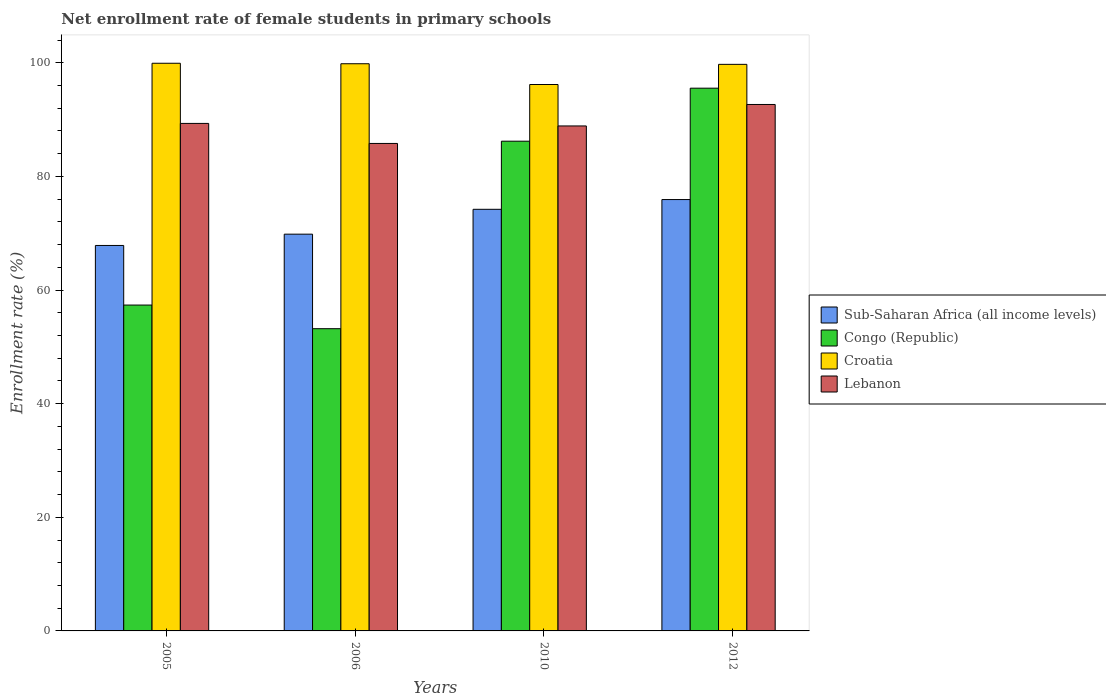How many groups of bars are there?
Your response must be concise. 4. Are the number of bars per tick equal to the number of legend labels?
Keep it short and to the point. Yes. How many bars are there on the 3rd tick from the right?
Offer a very short reply. 4. What is the net enrollment rate of female students in primary schools in Croatia in 2006?
Give a very brief answer. 99.83. Across all years, what is the maximum net enrollment rate of female students in primary schools in Lebanon?
Your answer should be compact. 92.67. Across all years, what is the minimum net enrollment rate of female students in primary schools in Lebanon?
Ensure brevity in your answer.  85.81. What is the total net enrollment rate of female students in primary schools in Croatia in the graph?
Your response must be concise. 395.66. What is the difference between the net enrollment rate of female students in primary schools in Croatia in 2010 and that in 2012?
Provide a succinct answer. -3.55. What is the difference between the net enrollment rate of female students in primary schools in Sub-Saharan Africa (all income levels) in 2010 and the net enrollment rate of female students in primary schools in Congo (Republic) in 2012?
Offer a terse response. -21.32. What is the average net enrollment rate of female students in primary schools in Congo (Republic) per year?
Your answer should be very brief. 73.07. In the year 2006, what is the difference between the net enrollment rate of female students in primary schools in Croatia and net enrollment rate of female students in primary schools in Congo (Republic)?
Your answer should be compact. 46.64. In how many years, is the net enrollment rate of female students in primary schools in Sub-Saharan Africa (all income levels) greater than 32 %?
Give a very brief answer. 4. What is the ratio of the net enrollment rate of female students in primary schools in Croatia in 2005 to that in 2010?
Provide a short and direct response. 1.04. Is the net enrollment rate of female students in primary schools in Congo (Republic) in 2006 less than that in 2010?
Your answer should be very brief. Yes. What is the difference between the highest and the second highest net enrollment rate of female students in primary schools in Lebanon?
Offer a terse response. 3.34. What is the difference between the highest and the lowest net enrollment rate of female students in primary schools in Congo (Republic)?
Provide a short and direct response. 42.34. In how many years, is the net enrollment rate of female students in primary schools in Lebanon greater than the average net enrollment rate of female students in primary schools in Lebanon taken over all years?
Your answer should be compact. 2. Is the sum of the net enrollment rate of female students in primary schools in Lebanon in 2010 and 2012 greater than the maximum net enrollment rate of female students in primary schools in Sub-Saharan Africa (all income levels) across all years?
Make the answer very short. Yes. Is it the case that in every year, the sum of the net enrollment rate of female students in primary schools in Sub-Saharan Africa (all income levels) and net enrollment rate of female students in primary schools in Lebanon is greater than the sum of net enrollment rate of female students in primary schools in Congo (Republic) and net enrollment rate of female students in primary schools in Croatia?
Your answer should be compact. No. What does the 3rd bar from the left in 2006 represents?
Provide a short and direct response. Croatia. What does the 2nd bar from the right in 2006 represents?
Ensure brevity in your answer.  Croatia. What is the difference between two consecutive major ticks on the Y-axis?
Ensure brevity in your answer.  20. Are the values on the major ticks of Y-axis written in scientific E-notation?
Provide a succinct answer. No. How many legend labels are there?
Your answer should be compact. 4. What is the title of the graph?
Your response must be concise. Net enrollment rate of female students in primary schools. Does "Northern Mariana Islands" appear as one of the legend labels in the graph?
Make the answer very short. No. What is the label or title of the Y-axis?
Your answer should be very brief. Enrollment rate (%). What is the Enrollment rate (%) of Sub-Saharan Africa (all income levels) in 2005?
Your response must be concise. 67.85. What is the Enrollment rate (%) of Congo (Republic) in 2005?
Offer a very short reply. 57.36. What is the Enrollment rate (%) of Croatia in 2005?
Your response must be concise. 99.92. What is the Enrollment rate (%) of Lebanon in 2005?
Keep it short and to the point. 89.33. What is the Enrollment rate (%) of Sub-Saharan Africa (all income levels) in 2006?
Offer a terse response. 69.84. What is the Enrollment rate (%) of Congo (Republic) in 2006?
Your answer should be very brief. 53.2. What is the Enrollment rate (%) of Croatia in 2006?
Ensure brevity in your answer.  99.83. What is the Enrollment rate (%) in Lebanon in 2006?
Provide a succinct answer. 85.81. What is the Enrollment rate (%) of Sub-Saharan Africa (all income levels) in 2010?
Your answer should be very brief. 74.21. What is the Enrollment rate (%) in Congo (Republic) in 2010?
Ensure brevity in your answer.  86.2. What is the Enrollment rate (%) in Croatia in 2010?
Your answer should be very brief. 96.18. What is the Enrollment rate (%) in Lebanon in 2010?
Offer a very short reply. 88.89. What is the Enrollment rate (%) in Sub-Saharan Africa (all income levels) in 2012?
Give a very brief answer. 75.93. What is the Enrollment rate (%) of Congo (Republic) in 2012?
Make the answer very short. 95.54. What is the Enrollment rate (%) in Croatia in 2012?
Your response must be concise. 99.73. What is the Enrollment rate (%) in Lebanon in 2012?
Your response must be concise. 92.67. Across all years, what is the maximum Enrollment rate (%) of Sub-Saharan Africa (all income levels)?
Your response must be concise. 75.93. Across all years, what is the maximum Enrollment rate (%) of Congo (Republic)?
Provide a short and direct response. 95.54. Across all years, what is the maximum Enrollment rate (%) in Croatia?
Provide a succinct answer. 99.92. Across all years, what is the maximum Enrollment rate (%) of Lebanon?
Make the answer very short. 92.67. Across all years, what is the minimum Enrollment rate (%) in Sub-Saharan Africa (all income levels)?
Make the answer very short. 67.85. Across all years, what is the minimum Enrollment rate (%) in Congo (Republic)?
Offer a terse response. 53.2. Across all years, what is the minimum Enrollment rate (%) of Croatia?
Provide a short and direct response. 96.18. Across all years, what is the minimum Enrollment rate (%) in Lebanon?
Offer a very short reply. 85.81. What is the total Enrollment rate (%) of Sub-Saharan Africa (all income levels) in the graph?
Make the answer very short. 287.83. What is the total Enrollment rate (%) in Congo (Republic) in the graph?
Ensure brevity in your answer.  292.3. What is the total Enrollment rate (%) in Croatia in the graph?
Provide a short and direct response. 395.66. What is the total Enrollment rate (%) of Lebanon in the graph?
Ensure brevity in your answer.  356.69. What is the difference between the Enrollment rate (%) of Sub-Saharan Africa (all income levels) in 2005 and that in 2006?
Make the answer very short. -1.99. What is the difference between the Enrollment rate (%) of Congo (Republic) in 2005 and that in 2006?
Keep it short and to the point. 4.16. What is the difference between the Enrollment rate (%) of Croatia in 2005 and that in 2006?
Your answer should be very brief. 0.09. What is the difference between the Enrollment rate (%) in Lebanon in 2005 and that in 2006?
Your response must be concise. 3.52. What is the difference between the Enrollment rate (%) in Sub-Saharan Africa (all income levels) in 2005 and that in 2010?
Provide a succinct answer. -6.37. What is the difference between the Enrollment rate (%) of Congo (Republic) in 2005 and that in 2010?
Provide a short and direct response. -28.84. What is the difference between the Enrollment rate (%) of Croatia in 2005 and that in 2010?
Ensure brevity in your answer.  3.74. What is the difference between the Enrollment rate (%) in Lebanon in 2005 and that in 2010?
Your answer should be compact. 0.45. What is the difference between the Enrollment rate (%) in Sub-Saharan Africa (all income levels) in 2005 and that in 2012?
Offer a terse response. -8.08. What is the difference between the Enrollment rate (%) of Congo (Republic) in 2005 and that in 2012?
Ensure brevity in your answer.  -38.17. What is the difference between the Enrollment rate (%) of Croatia in 2005 and that in 2012?
Your answer should be very brief. 0.19. What is the difference between the Enrollment rate (%) of Lebanon in 2005 and that in 2012?
Your response must be concise. -3.34. What is the difference between the Enrollment rate (%) in Sub-Saharan Africa (all income levels) in 2006 and that in 2010?
Offer a very short reply. -4.38. What is the difference between the Enrollment rate (%) of Congo (Republic) in 2006 and that in 2010?
Ensure brevity in your answer.  -33. What is the difference between the Enrollment rate (%) in Croatia in 2006 and that in 2010?
Keep it short and to the point. 3.65. What is the difference between the Enrollment rate (%) in Lebanon in 2006 and that in 2010?
Provide a succinct answer. -3.08. What is the difference between the Enrollment rate (%) of Sub-Saharan Africa (all income levels) in 2006 and that in 2012?
Ensure brevity in your answer.  -6.09. What is the difference between the Enrollment rate (%) of Congo (Republic) in 2006 and that in 2012?
Provide a short and direct response. -42.34. What is the difference between the Enrollment rate (%) of Croatia in 2006 and that in 2012?
Provide a short and direct response. 0.11. What is the difference between the Enrollment rate (%) of Lebanon in 2006 and that in 2012?
Provide a succinct answer. -6.86. What is the difference between the Enrollment rate (%) of Sub-Saharan Africa (all income levels) in 2010 and that in 2012?
Keep it short and to the point. -1.72. What is the difference between the Enrollment rate (%) of Congo (Republic) in 2010 and that in 2012?
Make the answer very short. -9.33. What is the difference between the Enrollment rate (%) in Croatia in 2010 and that in 2012?
Ensure brevity in your answer.  -3.55. What is the difference between the Enrollment rate (%) in Lebanon in 2010 and that in 2012?
Keep it short and to the point. -3.78. What is the difference between the Enrollment rate (%) of Sub-Saharan Africa (all income levels) in 2005 and the Enrollment rate (%) of Congo (Republic) in 2006?
Give a very brief answer. 14.65. What is the difference between the Enrollment rate (%) of Sub-Saharan Africa (all income levels) in 2005 and the Enrollment rate (%) of Croatia in 2006?
Offer a very short reply. -31.99. What is the difference between the Enrollment rate (%) in Sub-Saharan Africa (all income levels) in 2005 and the Enrollment rate (%) in Lebanon in 2006?
Your answer should be compact. -17.96. What is the difference between the Enrollment rate (%) of Congo (Republic) in 2005 and the Enrollment rate (%) of Croatia in 2006?
Ensure brevity in your answer.  -42.47. What is the difference between the Enrollment rate (%) of Congo (Republic) in 2005 and the Enrollment rate (%) of Lebanon in 2006?
Make the answer very short. -28.45. What is the difference between the Enrollment rate (%) in Croatia in 2005 and the Enrollment rate (%) in Lebanon in 2006?
Your answer should be compact. 14.11. What is the difference between the Enrollment rate (%) of Sub-Saharan Africa (all income levels) in 2005 and the Enrollment rate (%) of Congo (Republic) in 2010?
Make the answer very short. -18.35. What is the difference between the Enrollment rate (%) in Sub-Saharan Africa (all income levels) in 2005 and the Enrollment rate (%) in Croatia in 2010?
Your answer should be very brief. -28.33. What is the difference between the Enrollment rate (%) in Sub-Saharan Africa (all income levels) in 2005 and the Enrollment rate (%) in Lebanon in 2010?
Offer a very short reply. -21.04. What is the difference between the Enrollment rate (%) in Congo (Republic) in 2005 and the Enrollment rate (%) in Croatia in 2010?
Your response must be concise. -38.82. What is the difference between the Enrollment rate (%) of Congo (Republic) in 2005 and the Enrollment rate (%) of Lebanon in 2010?
Make the answer very short. -31.52. What is the difference between the Enrollment rate (%) of Croatia in 2005 and the Enrollment rate (%) of Lebanon in 2010?
Keep it short and to the point. 11.04. What is the difference between the Enrollment rate (%) in Sub-Saharan Africa (all income levels) in 2005 and the Enrollment rate (%) in Congo (Republic) in 2012?
Keep it short and to the point. -27.69. What is the difference between the Enrollment rate (%) of Sub-Saharan Africa (all income levels) in 2005 and the Enrollment rate (%) of Croatia in 2012?
Provide a succinct answer. -31.88. What is the difference between the Enrollment rate (%) of Sub-Saharan Africa (all income levels) in 2005 and the Enrollment rate (%) of Lebanon in 2012?
Your response must be concise. -24.82. What is the difference between the Enrollment rate (%) in Congo (Republic) in 2005 and the Enrollment rate (%) in Croatia in 2012?
Ensure brevity in your answer.  -42.37. What is the difference between the Enrollment rate (%) in Congo (Republic) in 2005 and the Enrollment rate (%) in Lebanon in 2012?
Provide a short and direct response. -35.31. What is the difference between the Enrollment rate (%) in Croatia in 2005 and the Enrollment rate (%) in Lebanon in 2012?
Offer a very short reply. 7.25. What is the difference between the Enrollment rate (%) in Sub-Saharan Africa (all income levels) in 2006 and the Enrollment rate (%) in Congo (Republic) in 2010?
Offer a terse response. -16.36. What is the difference between the Enrollment rate (%) in Sub-Saharan Africa (all income levels) in 2006 and the Enrollment rate (%) in Croatia in 2010?
Provide a short and direct response. -26.34. What is the difference between the Enrollment rate (%) of Sub-Saharan Africa (all income levels) in 2006 and the Enrollment rate (%) of Lebanon in 2010?
Offer a very short reply. -19.05. What is the difference between the Enrollment rate (%) in Congo (Republic) in 2006 and the Enrollment rate (%) in Croatia in 2010?
Your answer should be compact. -42.98. What is the difference between the Enrollment rate (%) of Congo (Republic) in 2006 and the Enrollment rate (%) of Lebanon in 2010?
Your answer should be compact. -35.69. What is the difference between the Enrollment rate (%) in Croatia in 2006 and the Enrollment rate (%) in Lebanon in 2010?
Make the answer very short. 10.95. What is the difference between the Enrollment rate (%) in Sub-Saharan Africa (all income levels) in 2006 and the Enrollment rate (%) in Congo (Republic) in 2012?
Your response must be concise. -25.7. What is the difference between the Enrollment rate (%) in Sub-Saharan Africa (all income levels) in 2006 and the Enrollment rate (%) in Croatia in 2012?
Your response must be concise. -29.89. What is the difference between the Enrollment rate (%) in Sub-Saharan Africa (all income levels) in 2006 and the Enrollment rate (%) in Lebanon in 2012?
Give a very brief answer. -22.83. What is the difference between the Enrollment rate (%) of Congo (Republic) in 2006 and the Enrollment rate (%) of Croatia in 2012?
Make the answer very short. -46.53. What is the difference between the Enrollment rate (%) of Congo (Republic) in 2006 and the Enrollment rate (%) of Lebanon in 2012?
Give a very brief answer. -39.47. What is the difference between the Enrollment rate (%) of Croatia in 2006 and the Enrollment rate (%) of Lebanon in 2012?
Offer a very short reply. 7.17. What is the difference between the Enrollment rate (%) of Sub-Saharan Africa (all income levels) in 2010 and the Enrollment rate (%) of Congo (Republic) in 2012?
Provide a succinct answer. -21.32. What is the difference between the Enrollment rate (%) of Sub-Saharan Africa (all income levels) in 2010 and the Enrollment rate (%) of Croatia in 2012?
Offer a terse response. -25.51. What is the difference between the Enrollment rate (%) in Sub-Saharan Africa (all income levels) in 2010 and the Enrollment rate (%) in Lebanon in 2012?
Offer a terse response. -18.45. What is the difference between the Enrollment rate (%) of Congo (Republic) in 2010 and the Enrollment rate (%) of Croatia in 2012?
Offer a very short reply. -13.53. What is the difference between the Enrollment rate (%) in Congo (Republic) in 2010 and the Enrollment rate (%) in Lebanon in 2012?
Give a very brief answer. -6.46. What is the difference between the Enrollment rate (%) of Croatia in 2010 and the Enrollment rate (%) of Lebanon in 2012?
Your answer should be compact. 3.51. What is the average Enrollment rate (%) of Sub-Saharan Africa (all income levels) per year?
Make the answer very short. 71.96. What is the average Enrollment rate (%) in Congo (Republic) per year?
Offer a very short reply. 73.07. What is the average Enrollment rate (%) of Croatia per year?
Offer a very short reply. 98.92. What is the average Enrollment rate (%) in Lebanon per year?
Keep it short and to the point. 89.17. In the year 2005, what is the difference between the Enrollment rate (%) in Sub-Saharan Africa (all income levels) and Enrollment rate (%) in Congo (Republic)?
Make the answer very short. 10.49. In the year 2005, what is the difference between the Enrollment rate (%) of Sub-Saharan Africa (all income levels) and Enrollment rate (%) of Croatia?
Offer a terse response. -32.07. In the year 2005, what is the difference between the Enrollment rate (%) of Sub-Saharan Africa (all income levels) and Enrollment rate (%) of Lebanon?
Offer a very short reply. -21.48. In the year 2005, what is the difference between the Enrollment rate (%) in Congo (Republic) and Enrollment rate (%) in Croatia?
Make the answer very short. -42.56. In the year 2005, what is the difference between the Enrollment rate (%) in Congo (Republic) and Enrollment rate (%) in Lebanon?
Provide a short and direct response. -31.97. In the year 2005, what is the difference between the Enrollment rate (%) in Croatia and Enrollment rate (%) in Lebanon?
Provide a short and direct response. 10.59. In the year 2006, what is the difference between the Enrollment rate (%) of Sub-Saharan Africa (all income levels) and Enrollment rate (%) of Congo (Republic)?
Your response must be concise. 16.64. In the year 2006, what is the difference between the Enrollment rate (%) of Sub-Saharan Africa (all income levels) and Enrollment rate (%) of Croatia?
Offer a terse response. -30. In the year 2006, what is the difference between the Enrollment rate (%) in Sub-Saharan Africa (all income levels) and Enrollment rate (%) in Lebanon?
Make the answer very short. -15.97. In the year 2006, what is the difference between the Enrollment rate (%) of Congo (Republic) and Enrollment rate (%) of Croatia?
Keep it short and to the point. -46.64. In the year 2006, what is the difference between the Enrollment rate (%) in Congo (Republic) and Enrollment rate (%) in Lebanon?
Your answer should be very brief. -32.61. In the year 2006, what is the difference between the Enrollment rate (%) of Croatia and Enrollment rate (%) of Lebanon?
Provide a short and direct response. 14.03. In the year 2010, what is the difference between the Enrollment rate (%) of Sub-Saharan Africa (all income levels) and Enrollment rate (%) of Congo (Republic)?
Provide a succinct answer. -11.99. In the year 2010, what is the difference between the Enrollment rate (%) of Sub-Saharan Africa (all income levels) and Enrollment rate (%) of Croatia?
Make the answer very short. -21.97. In the year 2010, what is the difference between the Enrollment rate (%) in Sub-Saharan Africa (all income levels) and Enrollment rate (%) in Lebanon?
Offer a terse response. -14.67. In the year 2010, what is the difference between the Enrollment rate (%) in Congo (Republic) and Enrollment rate (%) in Croatia?
Your answer should be compact. -9.98. In the year 2010, what is the difference between the Enrollment rate (%) in Congo (Republic) and Enrollment rate (%) in Lebanon?
Provide a succinct answer. -2.68. In the year 2010, what is the difference between the Enrollment rate (%) in Croatia and Enrollment rate (%) in Lebanon?
Offer a terse response. 7.29. In the year 2012, what is the difference between the Enrollment rate (%) of Sub-Saharan Africa (all income levels) and Enrollment rate (%) of Congo (Republic)?
Offer a terse response. -19.61. In the year 2012, what is the difference between the Enrollment rate (%) of Sub-Saharan Africa (all income levels) and Enrollment rate (%) of Croatia?
Ensure brevity in your answer.  -23.8. In the year 2012, what is the difference between the Enrollment rate (%) in Sub-Saharan Africa (all income levels) and Enrollment rate (%) in Lebanon?
Ensure brevity in your answer.  -16.74. In the year 2012, what is the difference between the Enrollment rate (%) of Congo (Republic) and Enrollment rate (%) of Croatia?
Ensure brevity in your answer.  -4.19. In the year 2012, what is the difference between the Enrollment rate (%) of Congo (Republic) and Enrollment rate (%) of Lebanon?
Offer a terse response. 2.87. In the year 2012, what is the difference between the Enrollment rate (%) of Croatia and Enrollment rate (%) of Lebanon?
Your answer should be compact. 7.06. What is the ratio of the Enrollment rate (%) in Sub-Saharan Africa (all income levels) in 2005 to that in 2006?
Provide a succinct answer. 0.97. What is the ratio of the Enrollment rate (%) in Congo (Republic) in 2005 to that in 2006?
Your answer should be compact. 1.08. What is the ratio of the Enrollment rate (%) in Lebanon in 2005 to that in 2006?
Offer a terse response. 1.04. What is the ratio of the Enrollment rate (%) in Sub-Saharan Africa (all income levels) in 2005 to that in 2010?
Offer a very short reply. 0.91. What is the ratio of the Enrollment rate (%) of Congo (Republic) in 2005 to that in 2010?
Your answer should be compact. 0.67. What is the ratio of the Enrollment rate (%) of Croatia in 2005 to that in 2010?
Your response must be concise. 1.04. What is the ratio of the Enrollment rate (%) of Sub-Saharan Africa (all income levels) in 2005 to that in 2012?
Provide a short and direct response. 0.89. What is the ratio of the Enrollment rate (%) of Congo (Republic) in 2005 to that in 2012?
Provide a succinct answer. 0.6. What is the ratio of the Enrollment rate (%) of Croatia in 2005 to that in 2012?
Your response must be concise. 1. What is the ratio of the Enrollment rate (%) in Sub-Saharan Africa (all income levels) in 2006 to that in 2010?
Provide a succinct answer. 0.94. What is the ratio of the Enrollment rate (%) in Congo (Republic) in 2006 to that in 2010?
Ensure brevity in your answer.  0.62. What is the ratio of the Enrollment rate (%) in Croatia in 2006 to that in 2010?
Offer a very short reply. 1.04. What is the ratio of the Enrollment rate (%) in Lebanon in 2006 to that in 2010?
Give a very brief answer. 0.97. What is the ratio of the Enrollment rate (%) in Sub-Saharan Africa (all income levels) in 2006 to that in 2012?
Offer a terse response. 0.92. What is the ratio of the Enrollment rate (%) in Congo (Republic) in 2006 to that in 2012?
Your response must be concise. 0.56. What is the ratio of the Enrollment rate (%) in Lebanon in 2006 to that in 2012?
Offer a terse response. 0.93. What is the ratio of the Enrollment rate (%) in Sub-Saharan Africa (all income levels) in 2010 to that in 2012?
Offer a terse response. 0.98. What is the ratio of the Enrollment rate (%) in Congo (Republic) in 2010 to that in 2012?
Provide a succinct answer. 0.9. What is the ratio of the Enrollment rate (%) of Croatia in 2010 to that in 2012?
Ensure brevity in your answer.  0.96. What is the ratio of the Enrollment rate (%) in Lebanon in 2010 to that in 2012?
Offer a terse response. 0.96. What is the difference between the highest and the second highest Enrollment rate (%) of Sub-Saharan Africa (all income levels)?
Your response must be concise. 1.72. What is the difference between the highest and the second highest Enrollment rate (%) in Congo (Republic)?
Give a very brief answer. 9.33. What is the difference between the highest and the second highest Enrollment rate (%) of Croatia?
Give a very brief answer. 0.09. What is the difference between the highest and the second highest Enrollment rate (%) in Lebanon?
Provide a short and direct response. 3.34. What is the difference between the highest and the lowest Enrollment rate (%) in Sub-Saharan Africa (all income levels)?
Your answer should be very brief. 8.08. What is the difference between the highest and the lowest Enrollment rate (%) in Congo (Republic)?
Your answer should be very brief. 42.34. What is the difference between the highest and the lowest Enrollment rate (%) of Croatia?
Offer a terse response. 3.74. What is the difference between the highest and the lowest Enrollment rate (%) of Lebanon?
Your response must be concise. 6.86. 